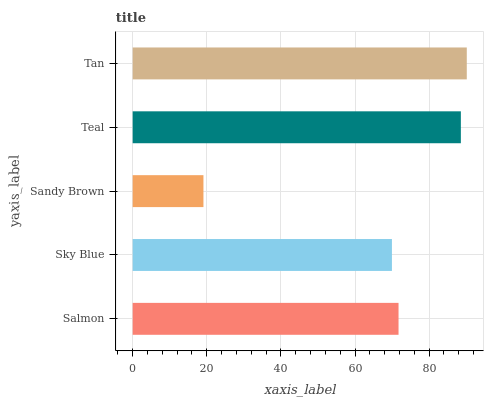Is Sandy Brown the minimum?
Answer yes or no. Yes. Is Tan the maximum?
Answer yes or no. Yes. Is Sky Blue the minimum?
Answer yes or no. No. Is Sky Blue the maximum?
Answer yes or no. No. Is Salmon greater than Sky Blue?
Answer yes or no. Yes. Is Sky Blue less than Salmon?
Answer yes or no. Yes. Is Sky Blue greater than Salmon?
Answer yes or no. No. Is Salmon less than Sky Blue?
Answer yes or no. No. Is Salmon the high median?
Answer yes or no. Yes. Is Salmon the low median?
Answer yes or no. Yes. Is Tan the high median?
Answer yes or no. No. Is Sky Blue the low median?
Answer yes or no. No. 